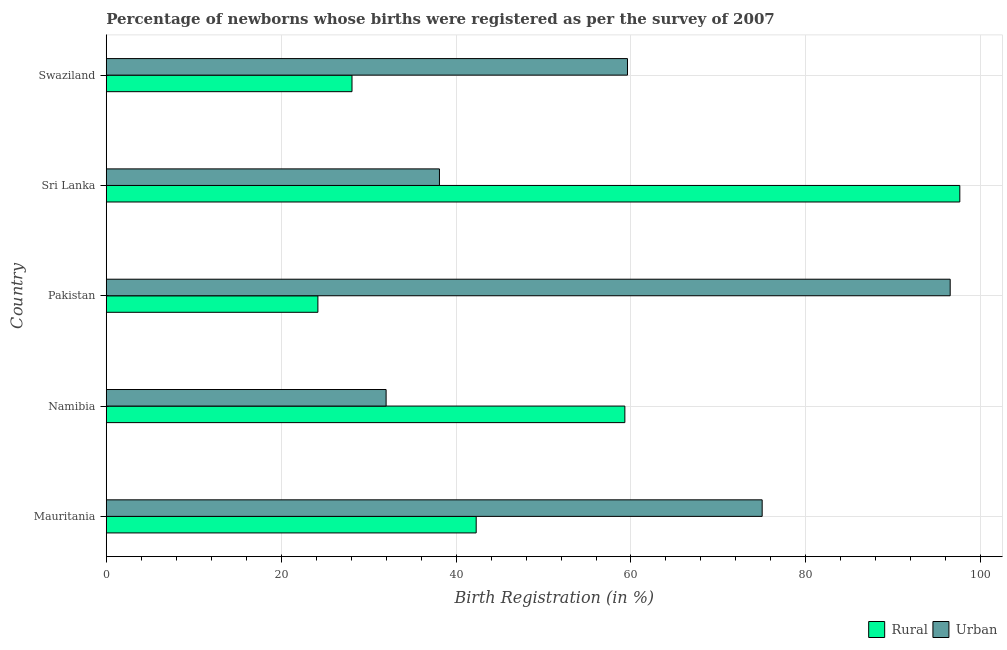How many different coloured bars are there?
Your response must be concise. 2. How many groups of bars are there?
Ensure brevity in your answer.  5. Are the number of bars on each tick of the Y-axis equal?
Give a very brief answer. Yes. How many bars are there on the 1st tick from the top?
Your response must be concise. 2. What is the label of the 4th group of bars from the top?
Give a very brief answer. Namibia. In how many cases, is the number of bars for a given country not equal to the number of legend labels?
Keep it short and to the point. 0. What is the rural birth registration in Pakistan?
Your answer should be very brief. 24.2. Across all countries, what is the maximum urban birth registration?
Give a very brief answer. 96.5. Across all countries, what is the minimum rural birth registration?
Your response must be concise. 24.2. In which country was the rural birth registration maximum?
Make the answer very short. Sri Lanka. What is the total rural birth registration in the graph?
Offer a terse response. 251.5. What is the difference between the urban birth registration in Mauritania and that in Pakistan?
Your answer should be very brief. -21.5. What is the difference between the urban birth registration in Pakistan and the rural birth registration in Swaziland?
Provide a short and direct response. 68.4. What is the average rural birth registration per country?
Provide a succinct answer. 50.3. What is the difference between the rural birth registration and urban birth registration in Sri Lanka?
Your response must be concise. 59.5. In how many countries, is the urban birth registration greater than 64 %?
Your answer should be compact. 2. What is the ratio of the rural birth registration in Mauritania to that in Swaziland?
Give a very brief answer. 1.5. Is the urban birth registration in Pakistan less than that in Sri Lanka?
Your answer should be very brief. No. What is the difference between the highest and the lowest rural birth registration?
Your answer should be compact. 73.4. In how many countries, is the urban birth registration greater than the average urban birth registration taken over all countries?
Provide a short and direct response. 2. Is the sum of the rural birth registration in Sri Lanka and Swaziland greater than the maximum urban birth registration across all countries?
Your answer should be compact. Yes. What does the 2nd bar from the top in Mauritania represents?
Provide a succinct answer. Rural. What does the 1st bar from the bottom in Pakistan represents?
Your answer should be compact. Rural. How many bars are there?
Your answer should be compact. 10. How many countries are there in the graph?
Keep it short and to the point. 5. What is the difference between two consecutive major ticks on the X-axis?
Your response must be concise. 20. Does the graph contain any zero values?
Provide a succinct answer. No. Does the graph contain grids?
Provide a succinct answer. Yes. Where does the legend appear in the graph?
Offer a very short reply. Bottom right. How many legend labels are there?
Offer a very short reply. 2. What is the title of the graph?
Offer a terse response. Percentage of newborns whose births were registered as per the survey of 2007. What is the label or title of the X-axis?
Give a very brief answer. Birth Registration (in %). What is the label or title of the Y-axis?
Your answer should be compact. Country. What is the Birth Registration (in %) of Rural in Mauritania?
Keep it short and to the point. 42.3. What is the Birth Registration (in %) of Rural in Namibia?
Ensure brevity in your answer.  59.3. What is the Birth Registration (in %) of Urban in Namibia?
Your answer should be compact. 32. What is the Birth Registration (in %) in Rural in Pakistan?
Offer a terse response. 24.2. What is the Birth Registration (in %) of Urban in Pakistan?
Ensure brevity in your answer.  96.5. What is the Birth Registration (in %) of Rural in Sri Lanka?
Give a very brief answer. 97.6. What is the Birth Registration (in %) in Urban in Sri Lanka?
Provide a short and direct response. 38.1. What is the Birth Registration (in %) in Rural in Swaziland?
Give a very brief answer. 28.1. What is the Birth Registration (in %) in Urban in Swaziland?
Your response must be concise. 59.6. Across all countries, what is the maximum Birth Registration (in %) of Rural?
Your answer should be compact. 97.6. Across all countries, what is the maximum Birth Registration (in %) of Urban?
Offer a very short reply. 96.5. Across all countries, what is the minimum Birth Registration (in %) in Rural?
Provide a succinct answer. 24.2. Across all countries, what is the minimum Birth Registration (in %) of Urban?
Your answer should be compact. 32. What is the total Birth Registration (in %) in Rural in the graph?
Make the answer very short. 251.5. What is the total Birth Registration (in %) of Urban in the graph?
Offer a terse response. 301.2. What is the difference between the Birth Registration (in %) of Rural in Mauritania and that in Namibia?
Provide a succinct answer. -17. What is the difference between the Birth Registration (in %) in Urban in Mauritania and that in Namibia?
Your answer should be compact. 43. What is the difference between the Birth Registration (in %) in Urban in Mauritania and that in Pakistan?
Make the answer very short. -21.5. What is the difference between the Birth Registration (in %) in Rural in Mauritania and that in Sri Lanka?
Your answer should be compact. -55.3. What is the difference between the Birth Registration (in %) of Urban in Mauritania and that in Sri Lanka?
Provide a succinct answer. 36.9. What is the difference between the Birth Registration (in %) in Rural in Mauritania and that in Swaziland?
Ensure brevity in your answer.  14.2. What is the difference between the Birth Registration (in %) of Rural in Namibia and that in Pakistan?
Provide a short and direct response. 35.1. What is the difference between the Birth Registration (in %) in Urban in Namibia and that in Pakistan?
Your response must be concise. -64.5. What is the difference between the Birth Registration (in %) of Rural in Namibia and that in Sri Lanka?
Keep it short and to the point. -38.3. What is the difference between the Birth Registration (in %) of Rural in Namibia and that in Swaziland?
Provide a succinct answer. 31.2. What is the difference between the Birth Registration (in %) in Urban in Namibia and that in Swaziland?
Offer a terse response. -27.6. What is the difference between the Birth Registration (in %) in Rural in Pakistan and that in Sri Lanka?
Offer a terse response. -73.4. What is the difference between the Birth Registration (in %) in Urban in Pakistan and that in Sri Lanka?
Ensure brevity in your answer.  58.4. What is the difference between the Birth Registration (in %) in Rural in Pakistan and that in Swaziland?
Give a very brief answer. -3.9. What is the difference between the Birth Registration (in %) of Urban in Pakistan and that in Swaziland?
Your response must be concise. 36.9. What is the difference between the Birth Registration (in %) in Rural in Sri Lanka and that in Swaziland?
Offer a terse response. 69.5. What is the difference between the Birth Registration (in %) in Urban in Sri Lanka and that in Swaziland?
Your answer should be compact. -21.5. What is the difference between the Birth Registration (in %) of Rural in Mauritania and the Birth Registration (in %) of Urban in Namibia?
Offer a terse response. 10.3. What is the difference between the Birth Registration (in %) of Rural in Mauritania and the Birth Registration (in %) of Urban in Pakistan?
Your answer should be compact. -54.2. What is the difference between the Birth Registration (in %) of Rural in Mauritania and the Birth Registration (in %) of Urban in Sri Lanka?
Give a very brief answer. 4.2. What is the difference between the Birth Registration (in %) in Rural in Mauritania and the Birth Registration (in %) in Urban in Swaziland?
Your response must be concise. -17.3. What is the difference between the Birth Registration (in %) of Rural in Namibia and the Birth Registration (in %) of Urban in Pakistan?
Keep it short and to the point. -37.2. What is the difference between the Birth Registration (in %) of Rural in Namibia and the Birth Registration (in %) of Urban in Sri Lanka?
Provide a short and direct response. 21.2. What is the difference between the Birth Registration (in %) in Rural in Namibia and the Birth Registration (in %) in Urban in Swaziland?
Provide a succinct answer. -0.3. What is the difference between the Birth Registration (in %) in Rural in Pakistan and the Birth Registration (in %) in Urban in Swaziland?
Offer a very short reply. -35.4. What is the average Birth Registration (in %) in Rural per country?
Your response must be concise. 50.3. What is the average Birth Registration (in %) of Urban per country?
Provide a succinct answer. 60.24. What is the difference between the Birth Registration (in %) in Rural and Birth Registration (in %) in Urban in Mauritania?
Offer a terse response. -32.7. What is the difference between the Birth Registration (in %) in Rural and Birth Registration (in %) in Urban in Namibia?
Keep it short and to the point. 27.3. What is the difference between the Birth Registration (in %) of Rural and Birth Registration (in %) of Urban in Pakistan?
Provide a succinct answer. -72.3. What is the difference between the Birth Registration (in %) in Rural and Birth Registration (in %) in Urban in Sri Lanka?
Provide a short and direct response. 59.5. What is the difference between the Birth Registration (in %) in Rural and Birth Registration (in %) in Urban in Swaziland?
Offer a very short reply. -31.5. What is the ratio of the Birth Registration (in %) of Rural in Mauritania to that in Namibia?
Keep it short and to the point. 0.71. What is the ratio of the Birth Registration (in %) of Urban in Mauritania to that in Namibia?
Make the answer very short. 2.34. What is the ratio of the Birth Registration (in %) of Rural in Mauritania to that in Pakistan?
Offer a terse response. 1.75. What is the ratio of the Birth Registration (in %) of Urban in Mauritania to that in Pakistan?
Provide a short and direct response. 0.78. What is the ratio of the Birth Registration (in %) of Rural in Mauritania to that in Sri Lanka?
Provide a succinct answer. 0.43. What is the ratio of the Birth Registration (in %) of Urban in Mauritania to that in Sri Lanka?
Offer a very short reply. 1.97. What is the ratio of the Birth Registration (in %) of Rural in Mauritania to that in Swaziland?
Keep it short and to the point. 1.51. What is the ratio of the Birth Registration (in %) of Urban in Mauritania to that in Swaziland?
Your response must be concise. 1.26. What is the ratio of the Birth Registration (in %) of Rural in Namibia to that in Pakistan?
Make the answer very short. 2.45. What is the ratio of the Birth Registration (in %) in Urban in Namibia to that in Pakistan?
Your response must be concise. 0.33. What is the ratio of the Birth Registration (in %) of Rural in Namibia to that in Sri Lanka?
Keep it short and to the point. 0.61. What is the ratio of the Birth Registration (in %) in Urban in Namibia to that in Sri Lanka?
Give a very brief answer. 0.84. What is the ratio of the Birth Registration (in %) of Rural in Namibia to that in Swaziland?
Provide a short and direct response. 2.11. What is the ratio of the Birth Registration (in %) in Urban in Namibia to that in Swaziland?
Make the answer very short. 0.54. What is the ratio of the Birth Registration (in %) in Rural in Pakistan to that in Sri Lanka?
Provide a succinct answer. 0.25. What is the ratio of the Birth Registration (in %) in Urban in Pakistan to that in Sri Lanka?
Give a very brief answer. 2.53. What is the ratio of the Birth Registration (in %) in Rural in Pakistan to that in Swaziland?
Ensure brevity in your answer.  0.86. What is the ratio of the Birth Registration (in %) in Urban in Pakistan to that in Swaziland?
Keep it short and to the point. 1.62. What is the ratio of the Birth Registration (in %) of Rural in Sri Lanka to that in Swaziland?
Give a very brief answer. 3.47. What is the ratio of the Birth Registration (in %) of Urban in Sri Lanka to that in Swaziland?
Make the answer very short. 0.64. What is the difference between the highest and the second highest Birth Registration (in %) in Rural?
Ensure brevity in your answer.  38.3. What is the difference between the highest and the lowest Birth Registration (in %) of Rural?
Your response must be concise. 73.4. What is the difference between the highest and the lowest Birth Registration (in %) of Urban?
Keep it short and to the point. 64.5. 